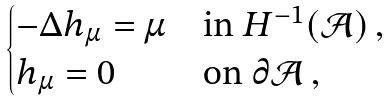<formula> <loc_0><loc_0><loc_500><loc_500>\begin{cases} - \Delta h _ { \mu } = \mu & \text {in $H^{-1}(\mathcal{A})$} \, , \\ h _ { \mu } = 0 & \text {on $\partial\mathcal{A}$} \, , \end{cases}</formula> 